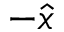Convert formula to latex. <formula><loc_0><loc_0><loc_500><loc_500>- \hat { x }</formula> 